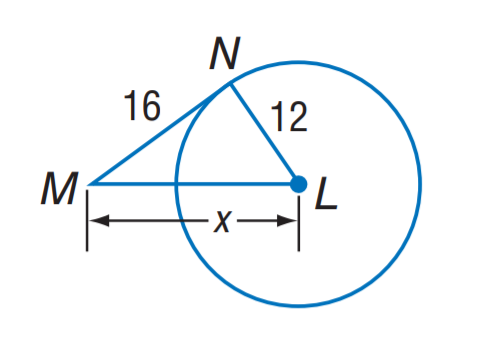Question: The segment is tangent to the circle. Find x.
Choices:
A. 12
B. 16
C. 20
D. 22
Answer with the letter. Answer: C 